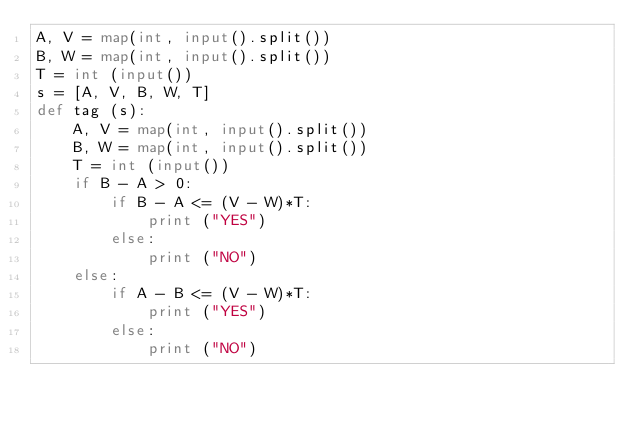<code> <loc_0><loc_0><loc_500><loc_500><_Python_>A, V = map(int, input().split())
B, W = map(int, input().split())
T = int (input())
s = [A, V, B, W, T]
def tag (s):
    A, V = map(int, input().split())
    B, W = map(int, input().split())
    T = int (input())
    if B - A > 0:
        if B - A <= (V - W)*T:
            print ("YES")
        else:
            print ("NO")
    else:
        if A - B <= (V - W)*T:
            print ("YES")
        else:
            print ("NO") </code> 